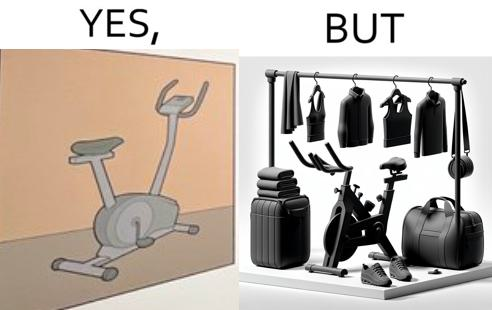What does this image depict? This is a satirical image with contrasting elements. 